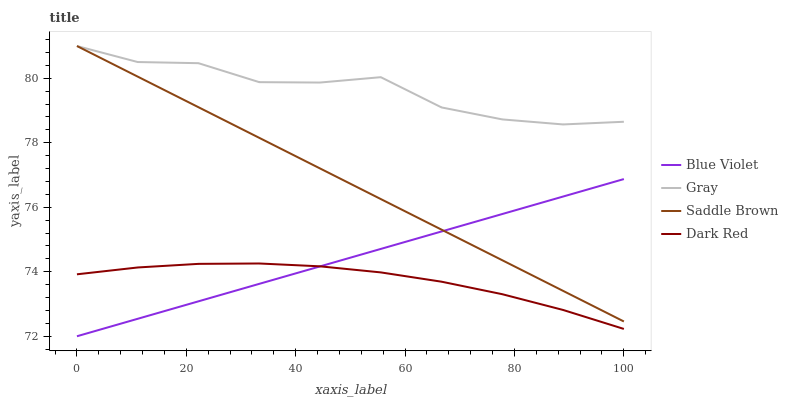Does Dark Red have the minimum area under the curve?
Answer yes or no. Yes. Does Gray have the maximum area under the curve?
Answer yes or no. Yes. Does Saddle Brown have the minimum area under the curve?
Answer yes or no. No. Does Saddle Brown have the maximum area under the curve?
Answer yes or no. No. Is Saddle Brown the smoothest?
Answer yes or no. Yes. Is Gray the roughest?
Answer yes or no. Yes. Is Blue Violet the smoothest?
Answer yes or no. No. Is Blue Violet the roughest?
Answer yes or no. No. Does Blue Violet have the lowest value?
Answer yes or no. Yes. Does Saddle Brown have the lowest value?
Answer yes or no. No. Does Saddle Brown have the highest value?
Answer yes or no. Yes. Does Blue Violet have the highest value?
Answer yes or no. No. Is Dark Red less than Saddle Brown?
Answer yes or no. Yes. Is Saddle Brown greater than Dark Red?
Answer yes or no. Yes. Does Gray intersect Saddle Brown?
Answer yes or no. Yes. Is Gray less than Saddle Brown?
Answer yes or no. No. Is Gray greater than Saddle Brown?
Answer yes or no. No. Does Dark Red intersect Saddle Brown?
Answer yes or no. No. 